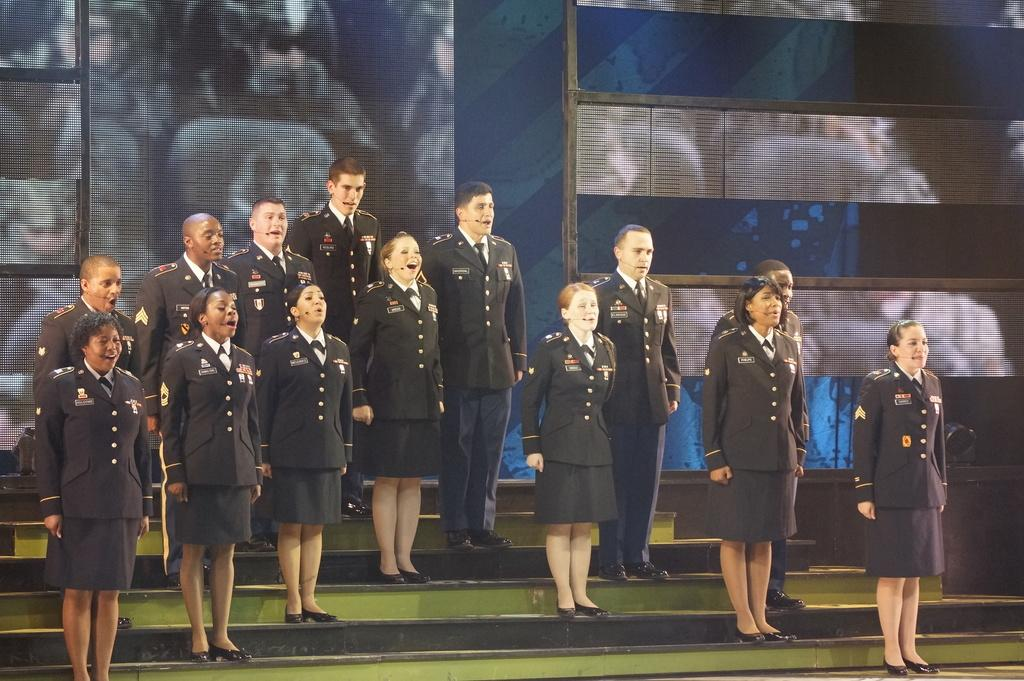How many people are in the image? There is a group of people in the image. Where are the people located in the image? The people are standing on a staircase. What can be seen in the background of the image? There is a wall and a screen in the background of the image. Can you tell if the image was taken during the day or night? The image was likely taken during the day. What type of sticks are the people using to move the egg in the image? There is no egg or sticks present in the image. 